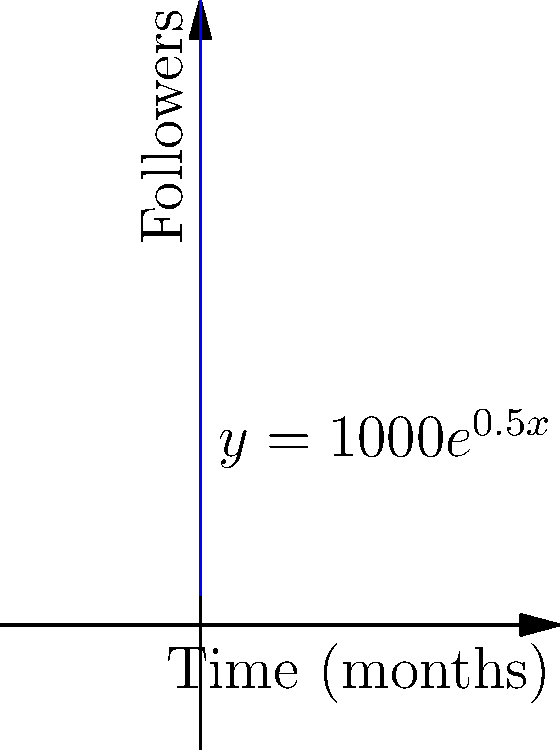Your transgender rights awareness campaign starts with 1000 social media followers. The graph shows the exponential growth of followers over time, represented by the function $y = 1000e^{0.5x}$, where $x$ is the number of months since the campaign started. After how many months will your campaign reach 10,000 followers? To solve this problem, we need to use the given exponential function and solve for $x$ when $y = 10,000$.

1) The function is $y = 1000e^{0.5x}$

2) We want to find $x$ when $y = 10,000$, so we set up the equation:
   $10,000 = 1000e^{0.5x}$

3) Divide both sides by 1000:
   $10 = e^{0.5x}$

4) Take the natural logarithm of both sides:
   $\ln(10) = \ln(e^{0.5x})$

5) Simplify the right side using the properties of logarithms:
   $\ln(10) = 0.5x$

6) Solve for $x$:
   $x = \frac{\ln(10)}{0.5} = 2\ln(10) \approx 4.605$

7) Since we're dealing with months, we round up to the nearest whole number.

Therefore, the campaign will reach 10,000 followers after 5 months.
Answer: 5 months 